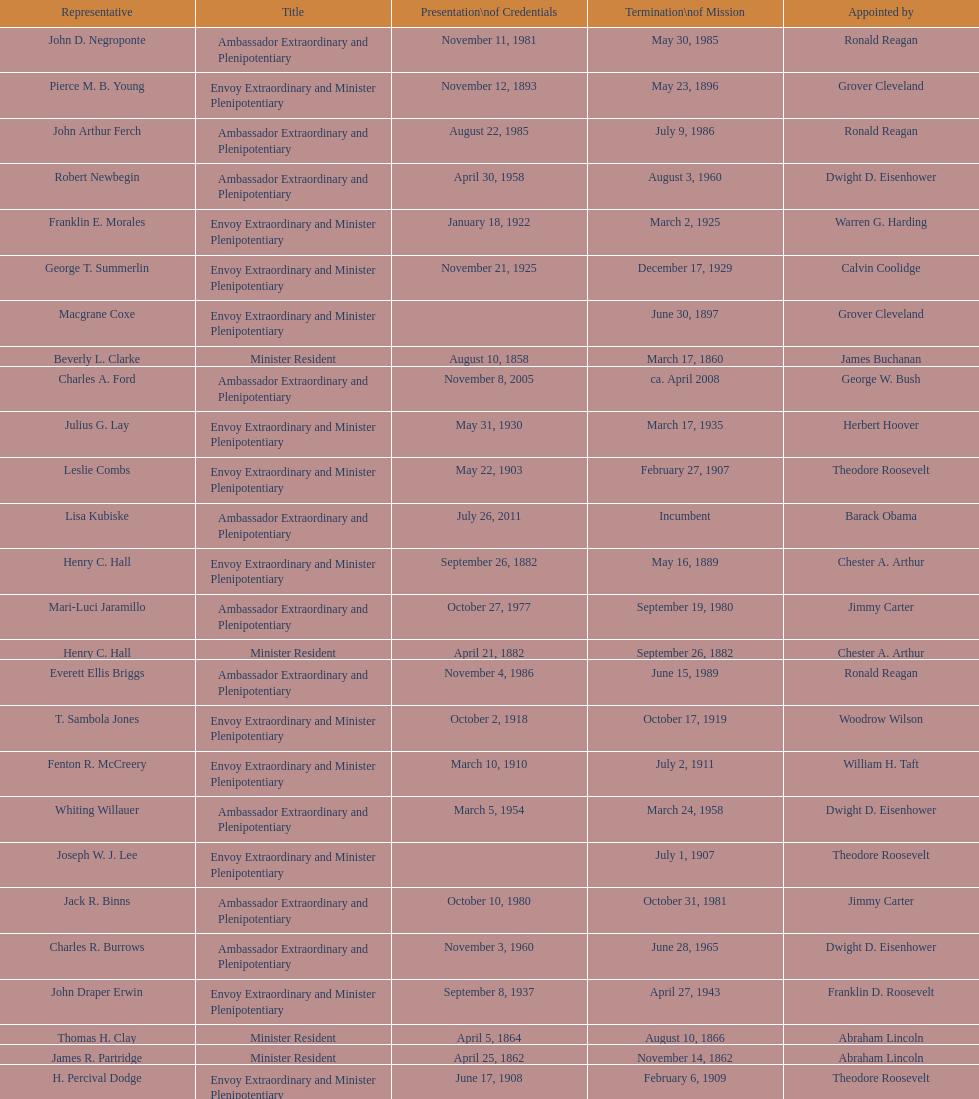Which date is below april 17, 1854 March 17, 1860. 